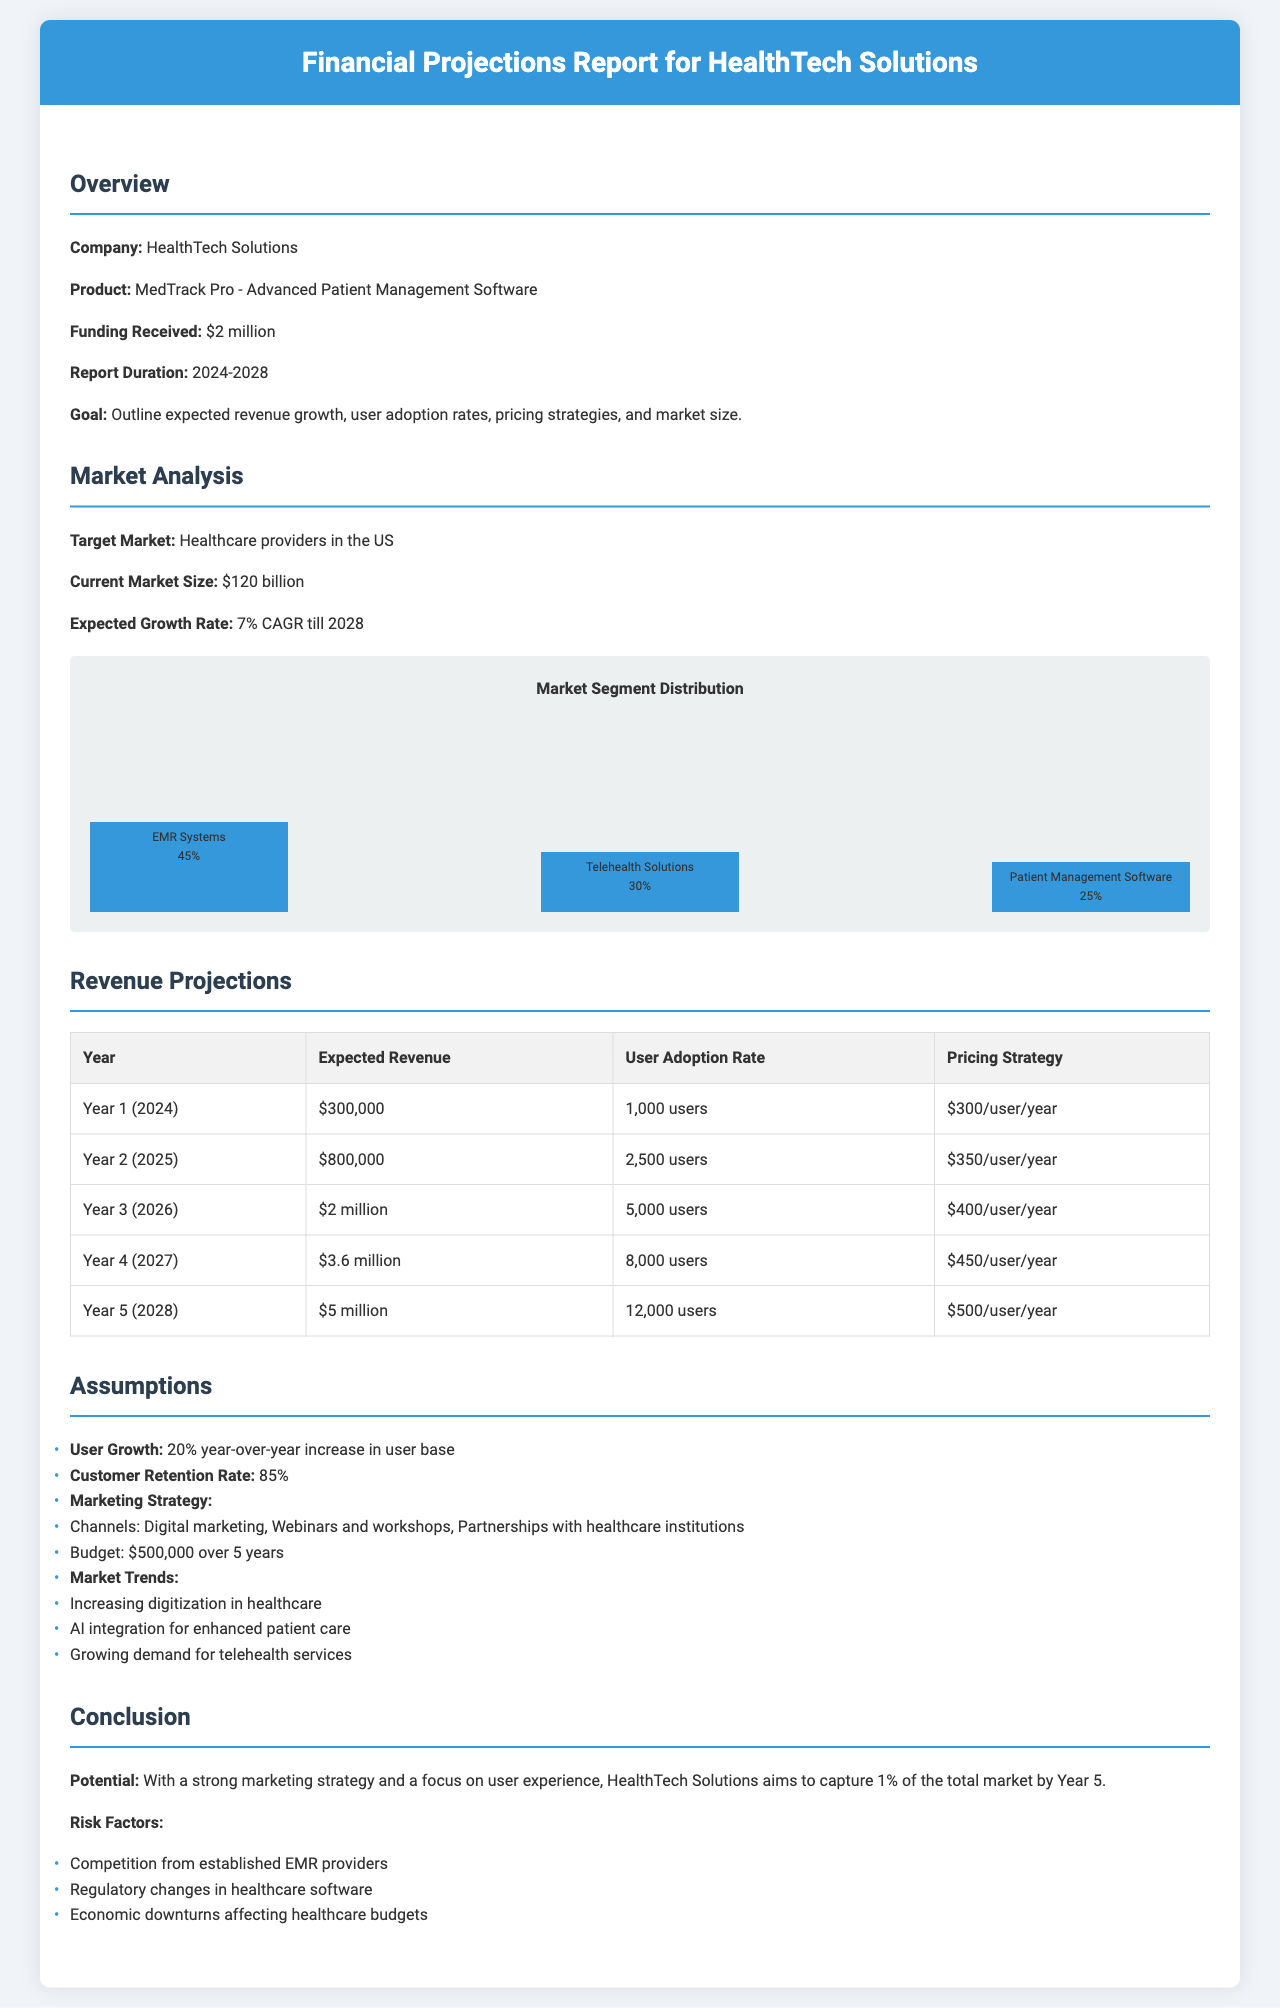what is the total funding received? The total funding received by HealthTech Solutions is stated directly in the overview section of the document.
Answer: $2 million what is the expected revenue in Year 3? The expected revenue for Year 3 (2026) is specifically listed in the revenue projections table.
Answer: $2 million what is the target market? The target market is identified in the market analysis section.
Answer: Healthcare providers in the US what is the customer retention rate? The customer retention rate is detailed under the assumptions section of the document.
Answer: 85% what is the expected growth rate of the current market size? This information is provided in the market analysis section, referring to the expected growth rate of the market.
Answer: 7% CAGR how many users are projected for Year 5? The projected number of users for Year 5 (2028) can be found in the revenue projections table.
Answer: 12,000 users what percentage of the market does HealthTech Solutions aim to capture by Year 5? This goal is mentioned in the conclusion of the document, specifically regarding market capture.
Answer: 1% what is the budget for the marketing strategy? The marketing strategy budget is mentioned in the assumptions section of the report.
Answer: $500,000 what is the expected revenue in Year 4? The expected revenue for Year 4 is specifically listed in the revenue projections table.
Answer: $3.6 million 